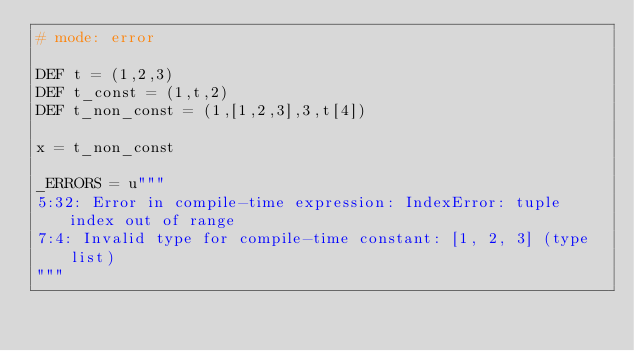<code> <loc_0><loc_0><loc_500><loc_500><_Cython_># mode: error

DEF t = (1,2,3)
DEF t_const = (1,t,2)
DEF t_non_const = (1,[1,2,3],3,t[4])

x = t_non_const

_ERRORS = u"""
5:32: Error in compile-time expression: IndexError: tuple index out of range
7:4: Invalid type for compile-time constant: [1, 2, 3] (type list)
"""
</code> 